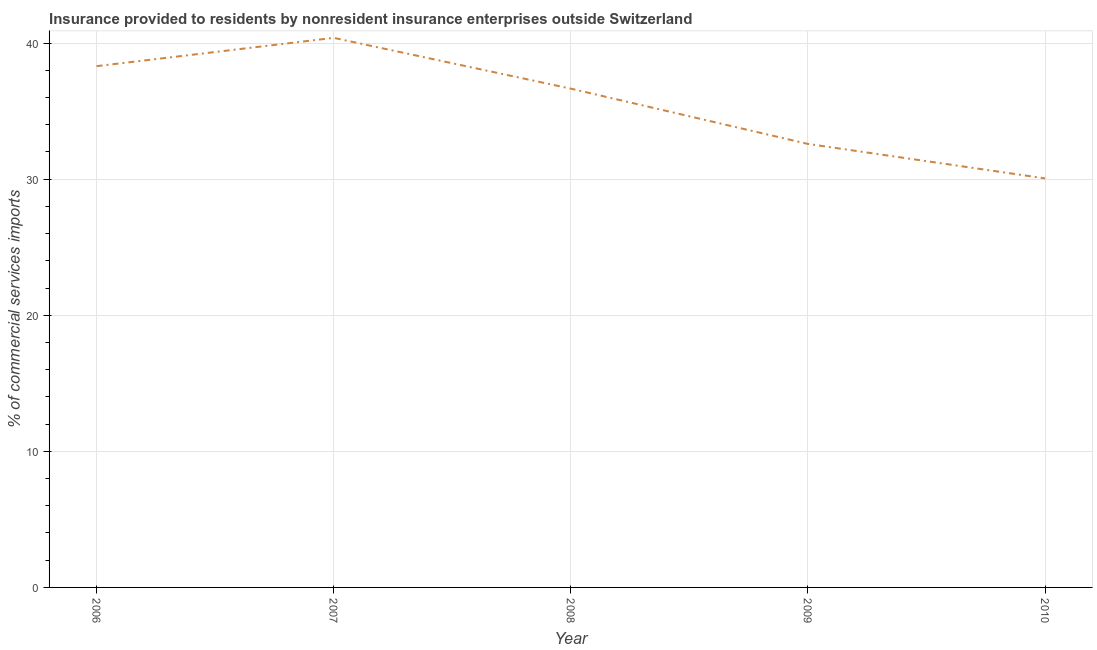What is the insurance provided by non-residents in 2010?
Offer a very short reply. 30.06. Across all years, what is the maximum insurance provided by non-residents?
Offer a terse response. 40.39. Across all years, what is the minimum insurance provided by non-residents?
Your answer should be very brief. 30.06. What is the sum of the insurance provided by non-residents?
Provide a succinct answer. 177.99. What is the difference between the insurance provided by non-residents in 2007 and 2008?
Offer a very short reply. 3.73. What is the average insurance provided by non-residents per year?
Provide a short and direct response. 35.6. What is the median insurance provided by non-residents?
Offer a terse response. 36.65. Do a majority of the years between 2009 and 2006 (inclusive) have insurance provided by non-residents greater than 32 %?
Provide a short and direct response. Yes. What is the ratio of the insurance provided by non-residents in 2006 to that in 2010?
Provide a succinct answer. 1.27. Is the difference between the insurance provided by non-residents in 2009 and 2010 greater than the difference between any two years?
Offer a terse response. No. What is the difference between the highest and the second highest insurance provided by non-residents?
Make the answer very short. 2.08. What is the difference between the highest and the lowest insurance provided by non-residents?
Offer a very short reply. 10.33. In how many years, is the insurance provided by non-residents greater than the average insurance provided by non-residents taken over all years?
Make the answer very short. 3. Does the insurance provided by non-residents monotonically increase over the years?
Offer a very short reply. No. How many lines are there?
Your answer should be compact. 1. What is the difference between two consecutive major ticks on the Y-axis?
Make the answer very short. 10. Are the values on the major ticks of Y-axis written in scientific E-notation?
Provide a succinct answer. No. What is the title of the graph?
Keep it short and to the point. Insurance provided to residents by nonresident insurance enterprises outside Switzerland. What is the label or title of the X-axis?
Ensure brevity in your answer.  Year. What is the label or title of the Y-axis?
Keep it short and to the point. % of commercial services imports. What is the % of commercial services imports in 2006?
Keep it short and to the point. 38.3. What is the % of commercial services imports in 2007?
Give a very brief answer. 40.39. What is the % of commercial services imports in 2008?
Ensure brevity in your answer.  36.65. What is the % of commercial services imports of 2009?
Provide a short and direct response. 32.59. What is the % of commercial services imports of 2010?
Your response must be concise. 30.06. What is the difference between the % of commercial services imports in 2006 and 2007?
Ensure brevity in your answer.  -2.08. What is the difference between the % of commercial services imports in 2006 and 2008?
Keep it short and to the point. 1.65. What is the difference between the % of commercial services imports in 2006 and 2009?
Give a very brief answer. 5.71. What is the difference between the % of commercial services imports in 2006 and 2010?
Your answer should be compact. 8.25. What is the difference between the % of commercial services imports in 2007 and 2008?
Give a very brief answer. 3.73. What is the difference between the % of commercial services imports in 2007 and 2009?
Your answer should be very brief. 7.8. What is the difference between the % of commercial services imports in 2007 and 2010?
Keep it short and to the point. 10.33. What is the difference between the % of commercial services imports in 2008 and 2009?
Provide a succinct answer. 4.06. What is the difference between the % of commercial services imports in 2008 and 2010?
Provide a short and direct response. 6.59. What is the difference between the % of commercial services imports in 2009 and 2010?
Your response must be concise. 2.53. What is the ratio of the % of commercial services imports in 2006 to that in 2007?
Your answer should be compact. 0.95. What is the ratio of the % of commercial services imports in 2006 to that in 2008?
Your answer should be very brief. 1.04. What is the ratio of the % of commercial services imports in 2006 to that in 2009?
Provide a succinct answer. 1.18. What is the ratio of the % of commercial services imports in 2006 to that in 2010?
Your answer should be very brief. 1.27. What is the ratio of the % of commercial services imports in 2007 to that in 2008?
Your response must be concise. 1.1. What is the ratio of the % of commercial services imports in 2007 to that in 2009?
Your response must be concise. 1.24. What is the ratio of the % of commercial services imports in 2007 to that in 2010?
Make the answer very short. 1.34. What is the ratio of the % of commercial services imports in 2008 to that in 2010?
Your answer should be compact. 1.22. What is the ratio of the % of commercial services imports in 2009 to that in 2010?
Offer a terse response. 1.08. 